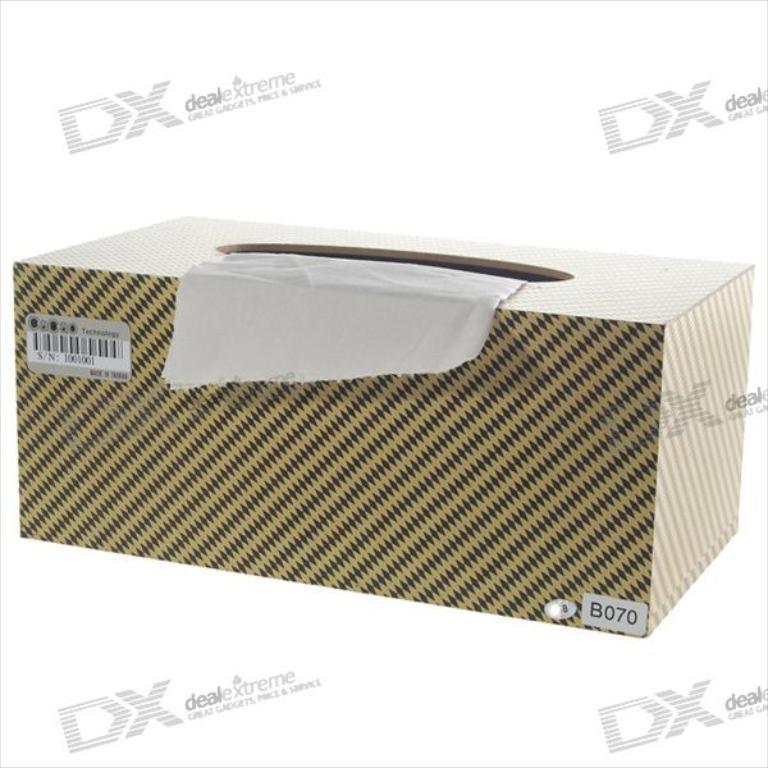What box number is this?
Offer a terse response. B070. Is dealextreme just a shipping company?
Keep it short and to the point. No. 